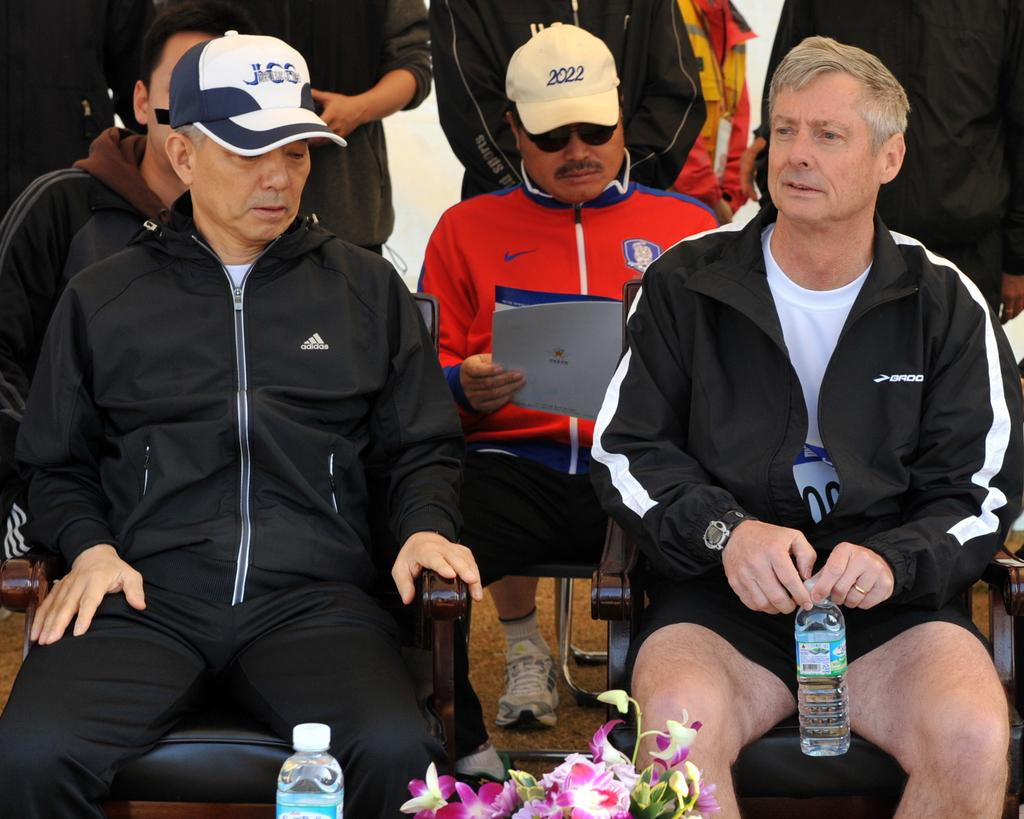<image>
Offer a succinct explanation of the picture presented. a man with a hat that has 2022 on it 